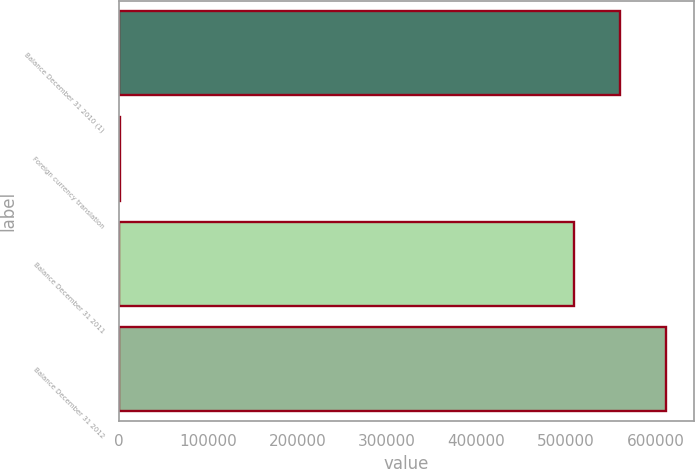Convert chart to OTSL. <chart><loc_0><loc_0><loc_500><loc_500><bar_chart><fcel>Balance December 31 2010 (1)<fcel>Foreign currency translation<fcel>Balance December 31 2011<fcel>Balance December 31 2012<nl><fcel>560329<fcel>1715<fcel>508550<fcel>612108<nl></chart> 